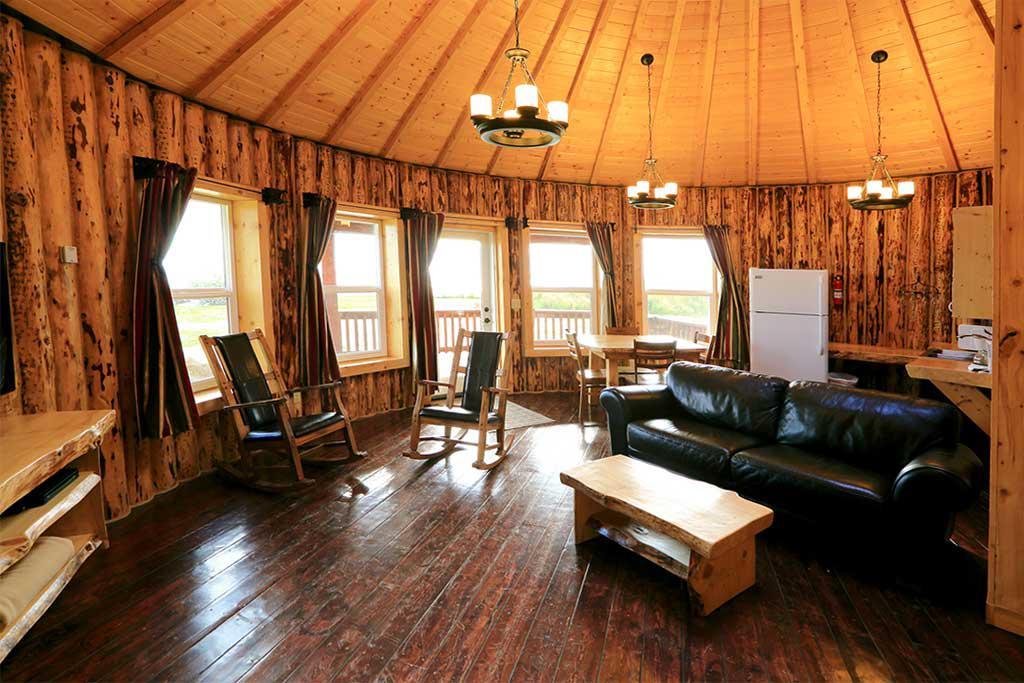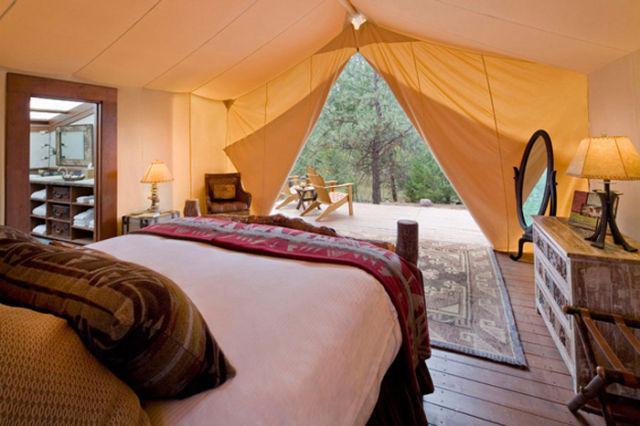The first image is the image on the left, the second image is the image on the right. Considering the images on both sides, is "One of the images has a ceiling fixture with at least three lights and the other image has no ceiling lights." valid? Answer yes or no. Yes. The first image is the image on the left, the second image is the image on the right. Analyze the images presented: Is the assertion "There are at least three chairs around a table located near the windows in one of the images." valid? Answer yes or no. Yes. 